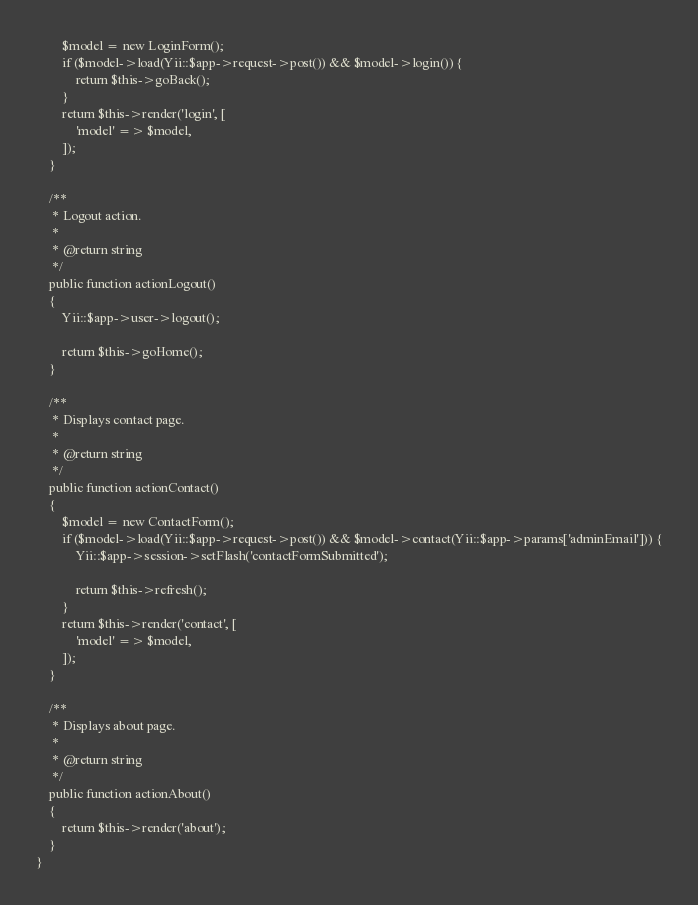<code> <loc_0><loc_0><loc_500><loc_500><_PHP_>        $model = new LoginForm();
        if ($model->load(Yii::$app->request->post()) && $model->login()) {
            return $this->goBack();
        }
        return $this->render('login', [
            'model' => $model,
        ]);
    }

    /**
     * Logout action.
     *
     * @return string
     */
    public function actionLogout()
    {
        Yii::$app->user->logout();

        return $this->goHome();
    }

    /**
     * Displays contact page.
     *
     * @return string
     */
    public function actionContact()
    {
        $model = new ContactForm();
        if ($model->load(Yii::$app->request->post()) && $model->contact(Yii::$app->params['adminEmail'])) {
            Yii::$app->session->setFlash('contactFormSubmitted');

            return $this->refresh();
        }
        return $this->render('contact', [
            'model' => $model,
        ]);
    }

    /**
     * Displays about page.
     *
     * @return string
     */
    public function actionAbout()
    {
        return $this->render('about');
    }
}
</code> 